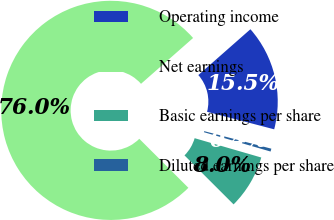Convert chart. <chart><loc_0><loc_0><loc_500><loc_500><pie_chart><fcel>Operating income<fcel>Net earnings<fcel>Basic earnings per share<fcel>Diluted earnings per share<nl><fcel>15.55%<fcel>76.03%<fcel>7.99%<fcel>0.43%<nl></chart> 